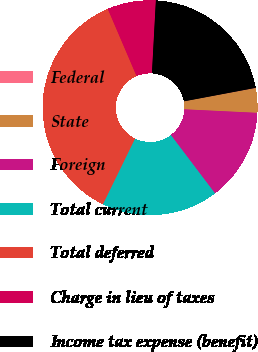<chart> <loc_0><loc_0><loc_500><loc_500><pie_chart><fcel>Federal<fcel>State<fcel>Foreign<fcel>Total current<fcel>Total deferred<fcel>Charge in lieu of taxes<fcel>Income tax expense (benefit)<nl><fcel>0.05%<fcel>3.68%<fcel>13.92%<fcel>17.55%<fcel>36.32%<fcel>7.3%<fcel>21.18%<nl></chart> 